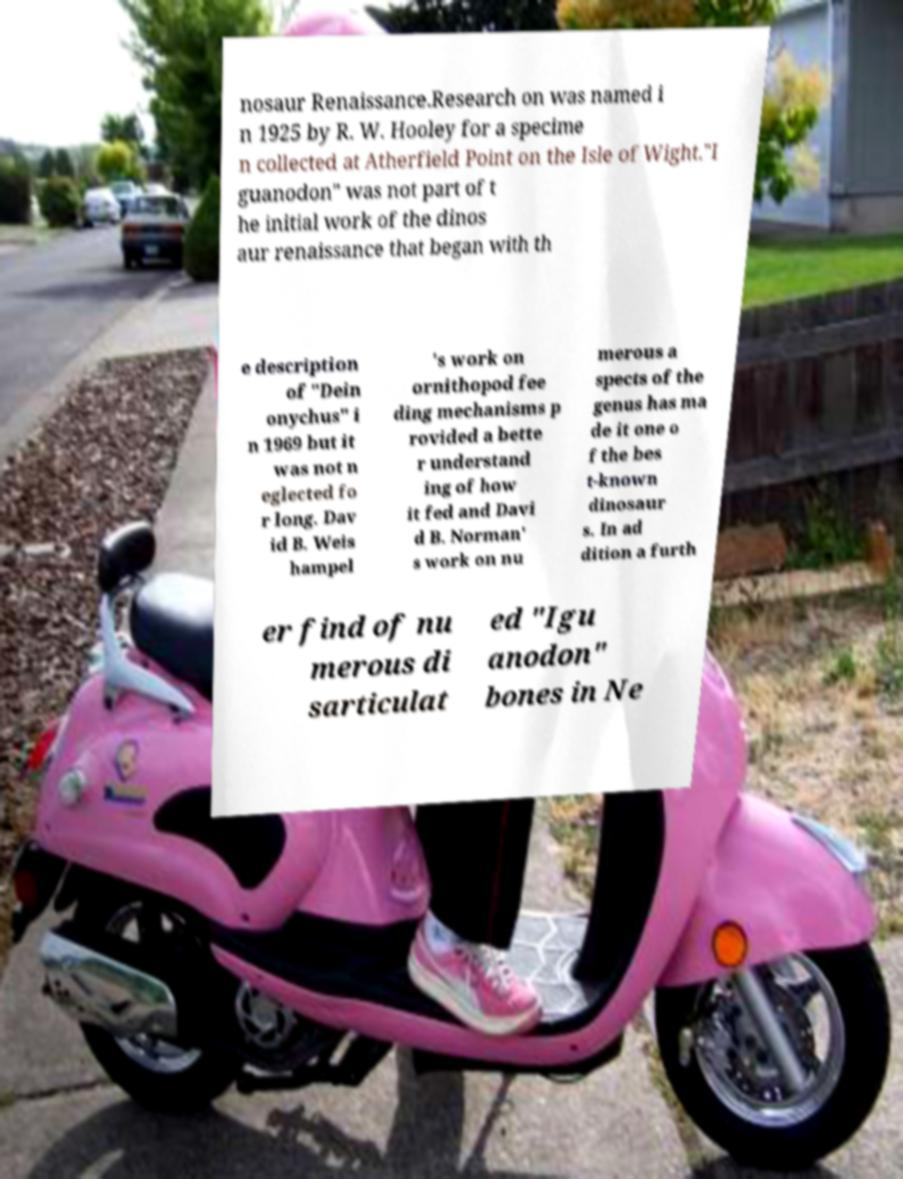Could you assist in decoding the text presented in this image and type it out clearly? nosaur Renaissance.Research on was named i n 1925 by R. W. Hooley for a specime n collected at Atherfield Point on the Isle of Wight."I guanodon" was not part of t he initial work of the dinos aur renaissance that began with th e description of "Dein onychus" i n 1969 but it was not n eglected fo r long. Dav id B. Weis hampel 's work on ornithopod fee ding mechanisms p rovided a bette r understand ing of how it fed and Davi d B. Norman' s work on nu merous a spects of the genus has ma de it one o f the bes t-known dinosaur s. In ad dition a furth er find of nu merous di sarticulat ed "Igu anodon" bones in Ne 